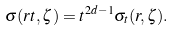Convert formula to latex. <formula><loc_0><loc_0><loc_500><loc_500>\sigma ( r t , \zeta ) = t ^ { 2 d - 1 } \sigma _ { t } ( r , \zeta ) .</formula> 